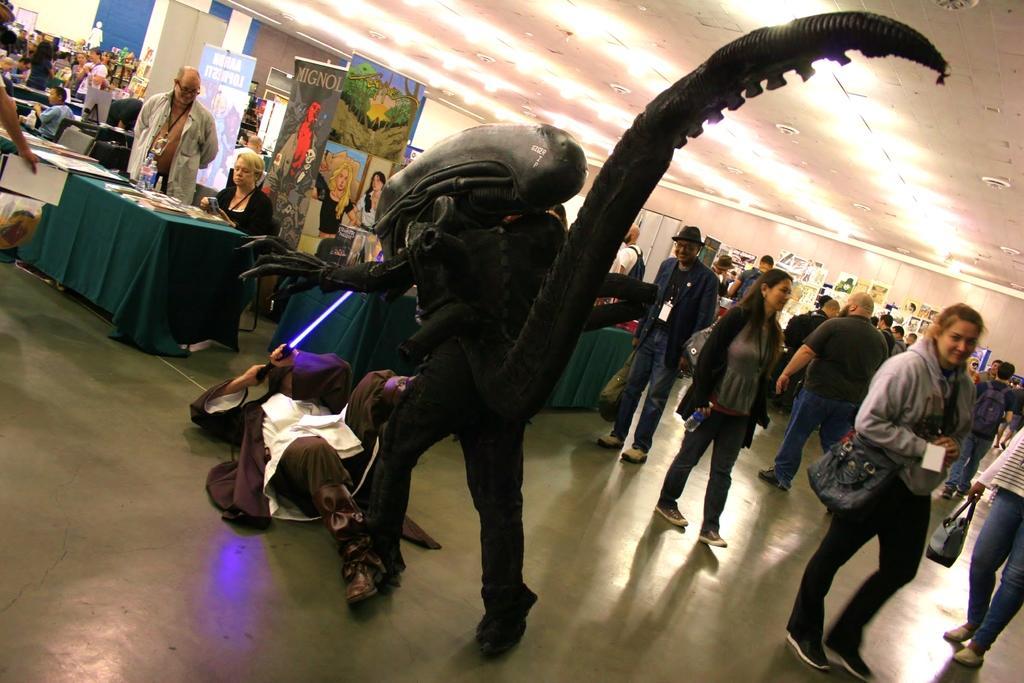Could you give a brief overview of what you see in this image? In this image there are a group of people who are walking some of them are sitting on chairs, and also we could see some tables. On the tables there are some papers, in the foreground there is one person who is holding some stick and fighting. In front of him there is one person who is wearing some costume. At the bottom there is floor, at the top of the image there is ceiling and some lights and also we could see some photo frames on the wall on the right side and on the left side there are some boards. On the boards there is some text. 